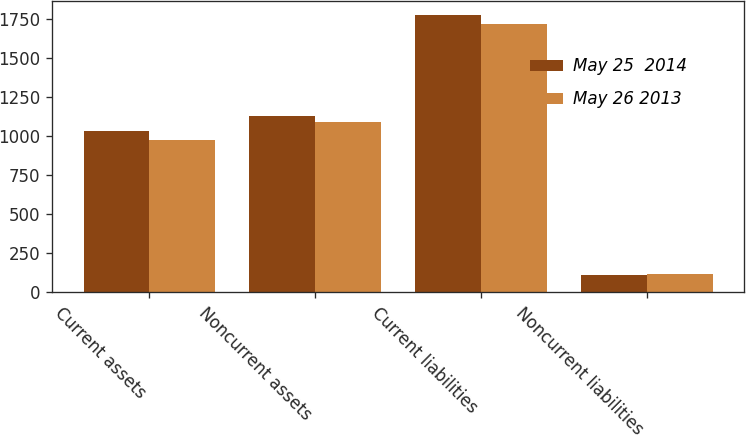<chart> <loc_0><loc_0><loc_500><loc_500><stacked_bar_chart><ecel><fcel>Current assets<fcel>Noncurrent assets<fcel>Current liabilities<fcel>Noncurrent liabilities<nl><fcel>May 25  2014<fcel>1031.1<fcel>1129.8<fcel>1779<fcel>110.3<nl><fcel>May 26 2013<fcel>976.7<fcel>1088.2<fcel>1717.4<fcel>115.1<nl></chart> 